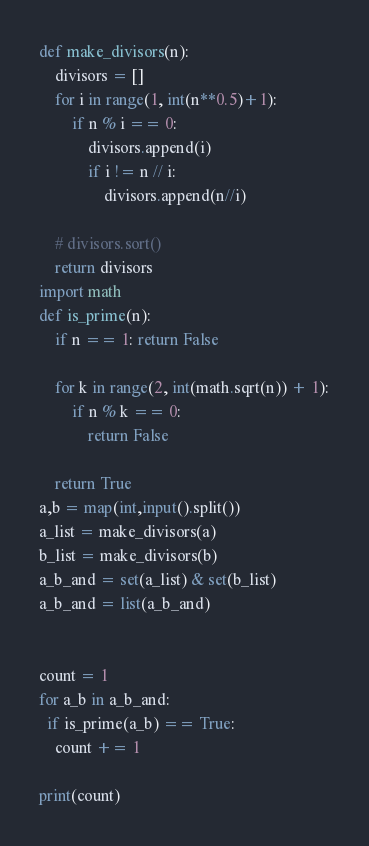Convert code to text. <code><loc_0><loc_0><loc_500><loc_500><_Python_>
def make_divisors(n):
    divisors = []
    for i in range(1, int(n**0.5)+1):
        if n % i == 0:
            divisors.append(i)
            if i != n // i:
                divisors.append(n//i)

    # divisors.sort()
    return divisors
import math
def is_prime(n):
    if n == 1: return False

    for k in range(2, int(math.sqrt(n)) + 1):
        if n % k == 0:
            return False

    return True  
a,b = map(int,input().split())
a_list = make_divisors(a)
b_list = make_divisors(b)
a_b_and = set(a_list) & set(b_list)
a_b_and = list(a_b_and)


count = 1
for a_b in a_b_and:
  if is_prime(a_b) == True:
    count += 1
    
print(count)</code> 